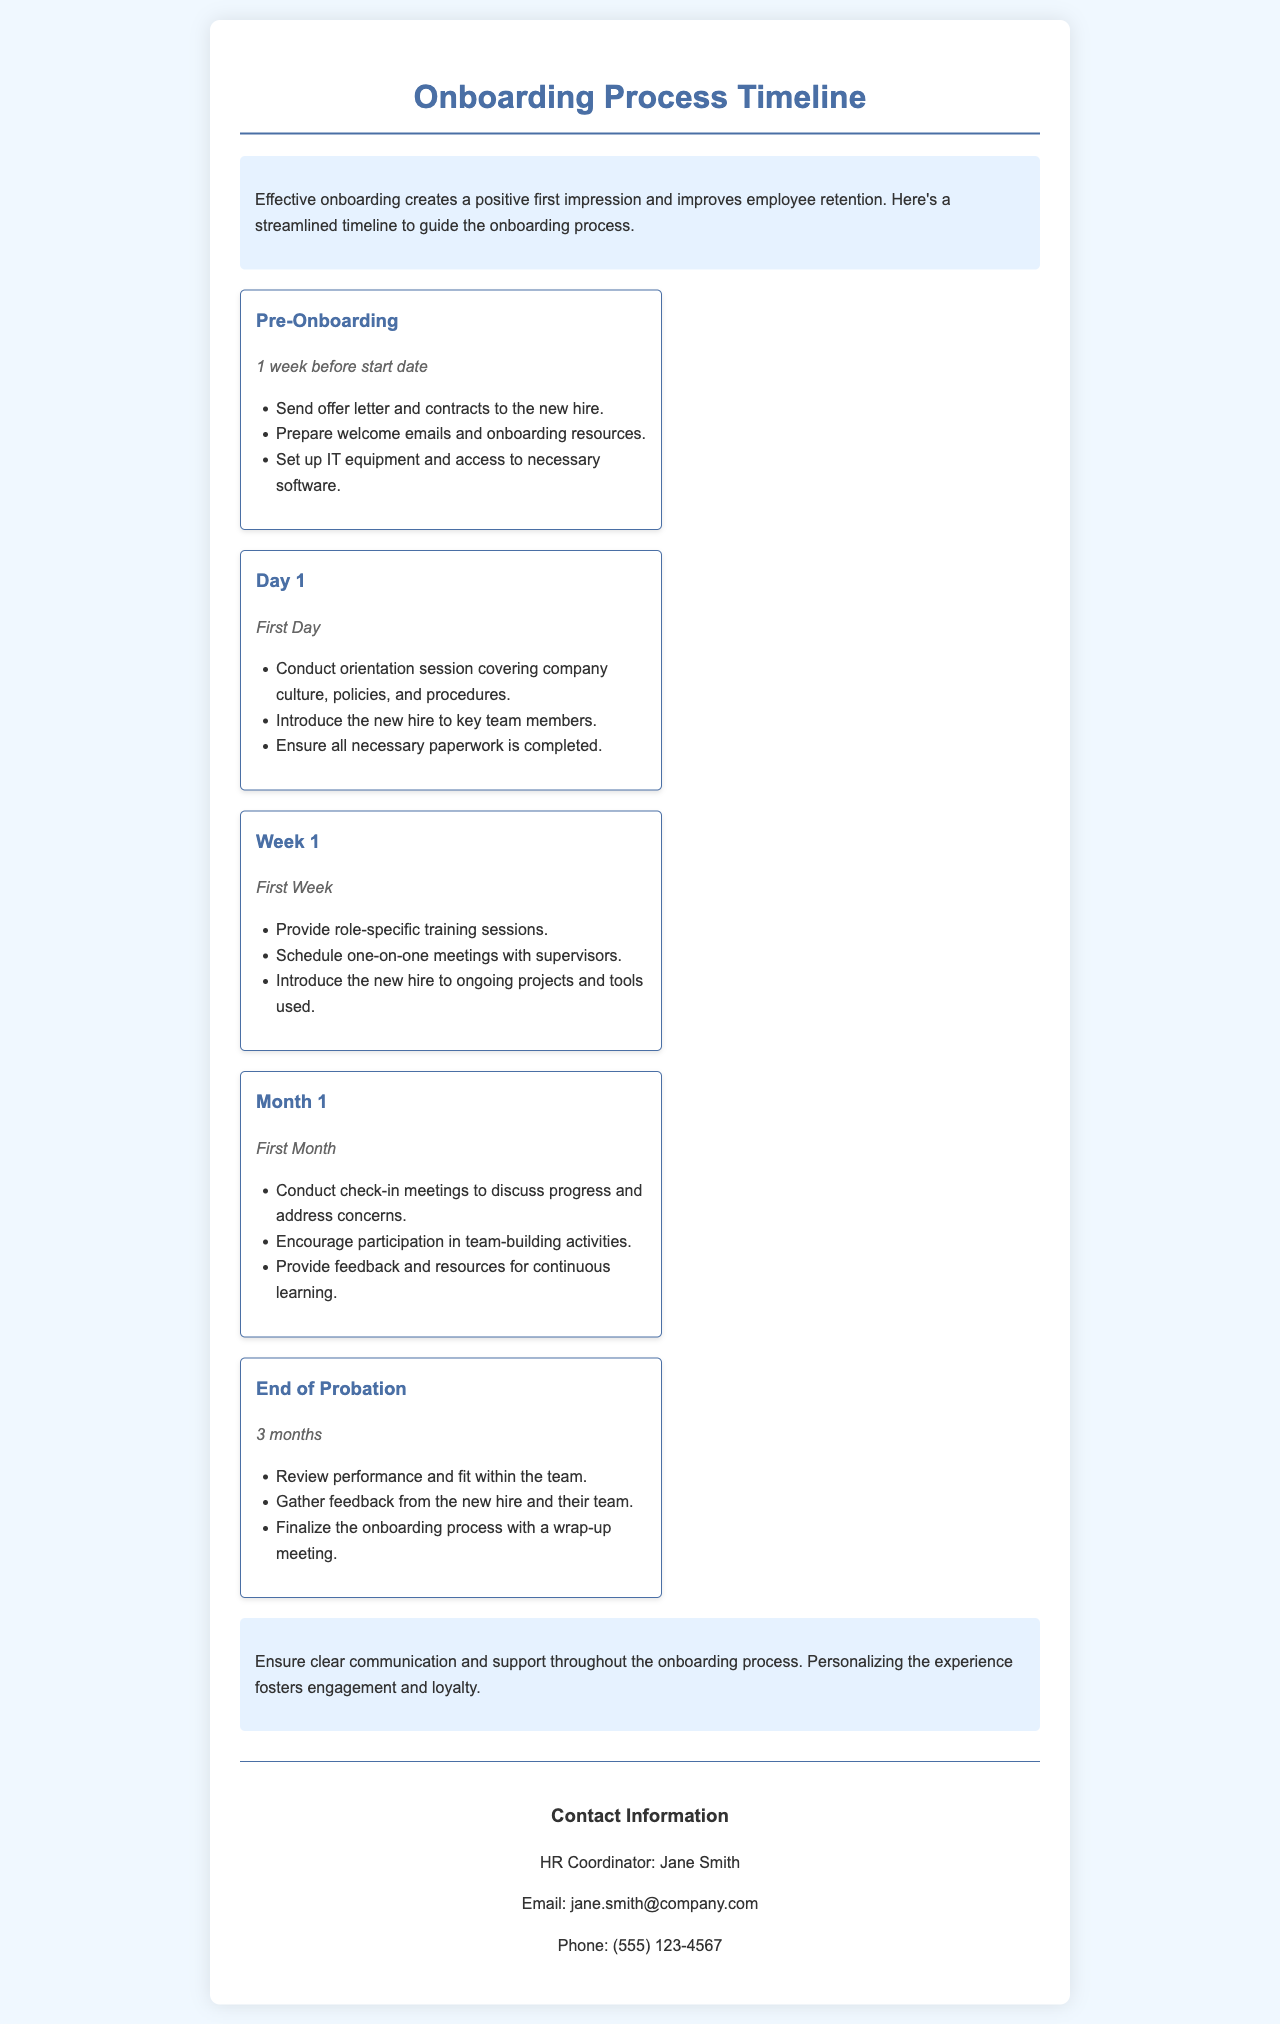What is the main purpose of onboarding? The document states that effective onboarding creates a positive first impression and improves employee retention.
Answer: Improving employee retention How long is the pre-onboarding stage? The timeline specifies that pre-onboarding occurs 1 week before the start date.
Answer: 1 week Who is the HR coordinator listed in the document? The contact information section names Jane Smith as the HR Coordinator.
Answer: Jane Smith What activities are suggested for the first month? The document lists check-in meetings, team-building activities, and feedback as activities in the first month.
Answer: Check-in meetings, team-building activities, feedback How long is the probation period mentioned? The timeline indicates that the end of probation is evaluated after 3 months.
Answer: 3 months What is emphasized as important throughout the onboarding process? The tips section notes that clear communication and support are important throughout onboarding.
Answer: Clear communication and support What is covered in the orientation session on Day 1? The document states that the orientation session on Day 1 covers company culture, policies, and procedures.
Answer: Company culture, policies, and procedures What is included in the first week of onboarding? The first week includes role-specific training sessions and meetings with supervisors.
Answer: Role-specific training sessions, one-on-one meetings Which aspect of onboarding helps foster engagement according to the tips? The document mentions that personalizing the experience fosters engagement and loyalty.
Answer: Personalizing the experience 